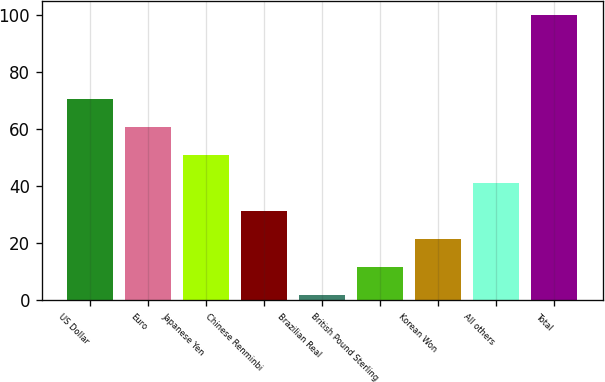Convert chart. <chart><loc_0><loc_0><loc_500><loc_500><bar_chart><fcel>US Dollar<fcel>Euro<fcel>Japanese Yen<fcel>Chinese Renminbi<fcel>Brazilian Real<fcel>British Pound Sterling<fcel>Korean Won<fcel>All others<fcel>Total<nl><fcel>70.6<fcel>60.8<fcel>51<fcel>31.4<fcel>2<fcel>11.8<fcel>21.6<fcel>41.2<fcel>100<nl></chart> 